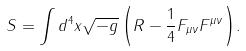Convert formula to latex. <formula><loc_0><loc_0><loc_500><loc_500>S = \int { d ^ { 4 } x \sqrt { - g } \left ( { R - \frac { 1 } { 4 } F _ { \mu \nu } F ^ { \mu \nu } } \right ) } .</formula> 